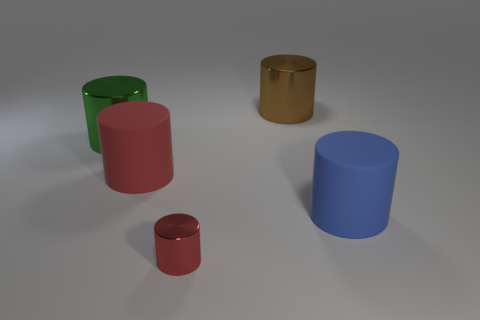Do the rubber cylinder that is to the left of the tiny red metal thing and the shiny thing in front of the large green shiny cylinder have the same color?
Your answer should be compact. Yes. Is the number of big matte objects that are behind the blue rubber cylinder greater than the number of big red metal things?
Your answer should be compact. Yes. What material is the blue thing?
Give a very brief answer. Rubber. The large brown thing that is the same material as the large green object is what shape?
Provide a succinct answer. Cylinder. What is the size of the matte thing in front of the big matte thing that is left of the tiny red metallic cylinder?
Your answer should be very brief. Large. What is the color of the thing that is in front of the large blue matte thing?
Ensure brevity in your answer.  Red. Are there any other big brown shiny objects of the same shape as the big brown metallic thing?
Offer a terse response. No. Are there fewer large metal cylinders that are left of the large green cylinder than red rubber objects behind the big red matte object?
Provide a succinct answer. No. The small metal cylinder is what color?
Give a very brief answer. Red. There is a metallic cylinder that is in front of the green shiny cylinder; are there any objects that are on the right side of it?
Offer a terse response. Yes. 